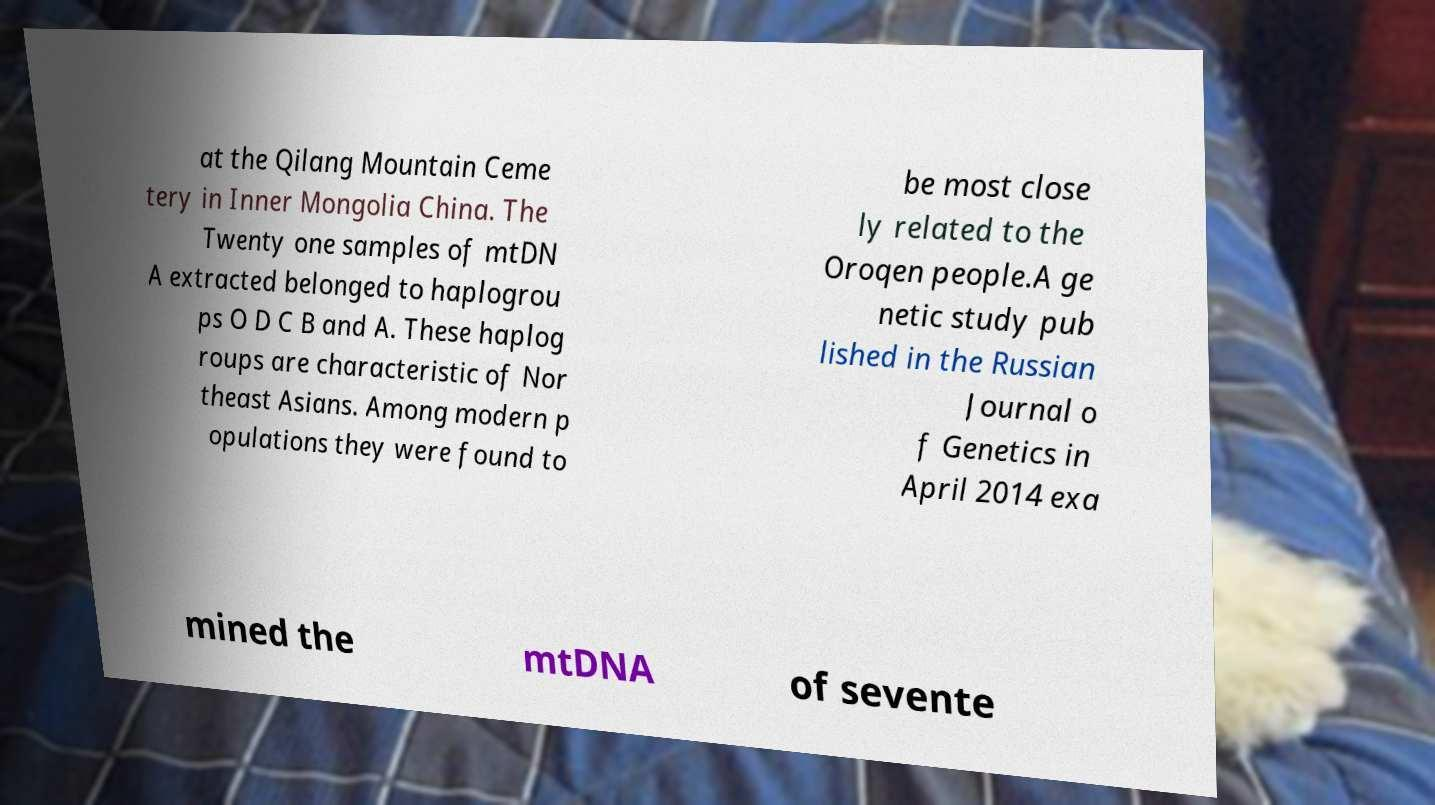Can you accurately transcribe the text from the provided image for me? at the Qilang Mountain Ceme tery in Inner Mongolia China. The Twenty one samples of mtDN A extracted belonged to haplogrou ps O D C B and A. These haplog roups are characteristic of Nor theast Asians. Among modern p opulations they were found to be most close ly related to the Oroqen people.A ge netic study pub lished in the Russian Journal o f Genetics in April 2014 exa mined the mtDNA of sevente 